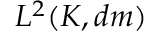<formula> <loc_0><loc_0><loc_500><loc_500>L ^ { 2 } ( K , d m )</formula> 